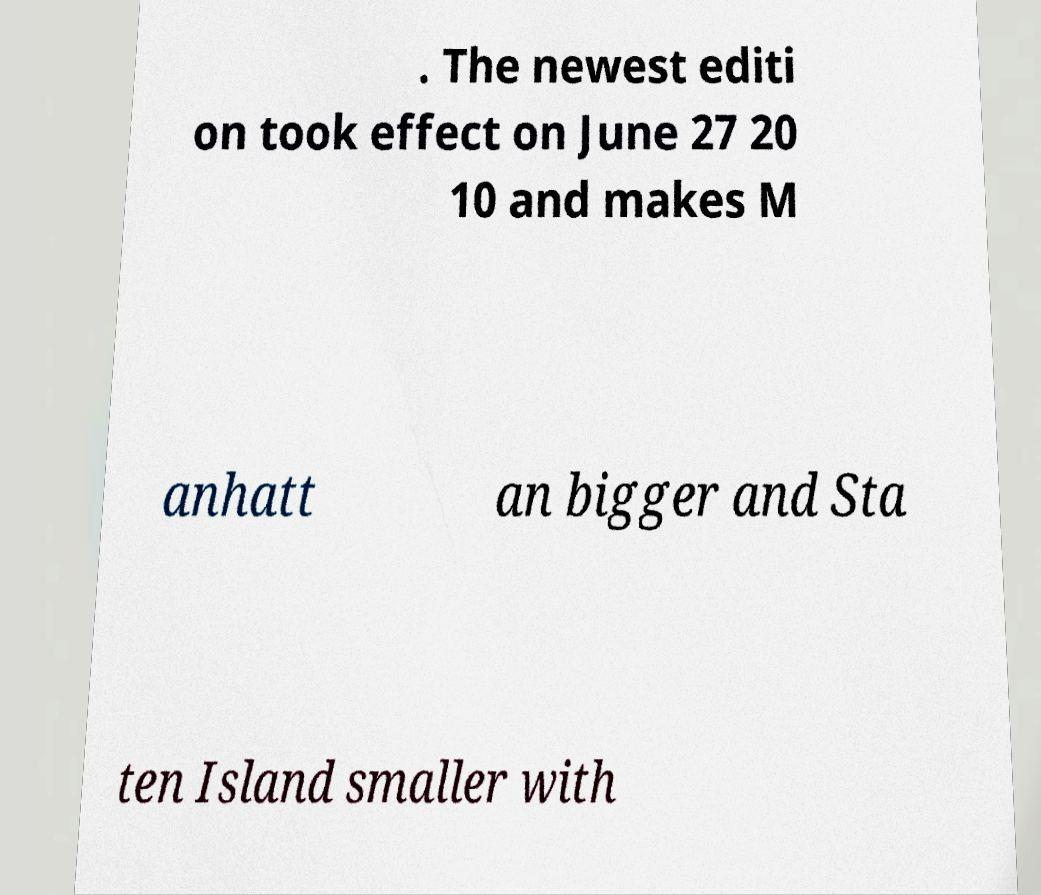Can you accurately transcribe the text from the provided image for me? . The newest editi on took effect on June 27 20 10 and makes M anhatt an bigger and Sta ten Island smaller with 